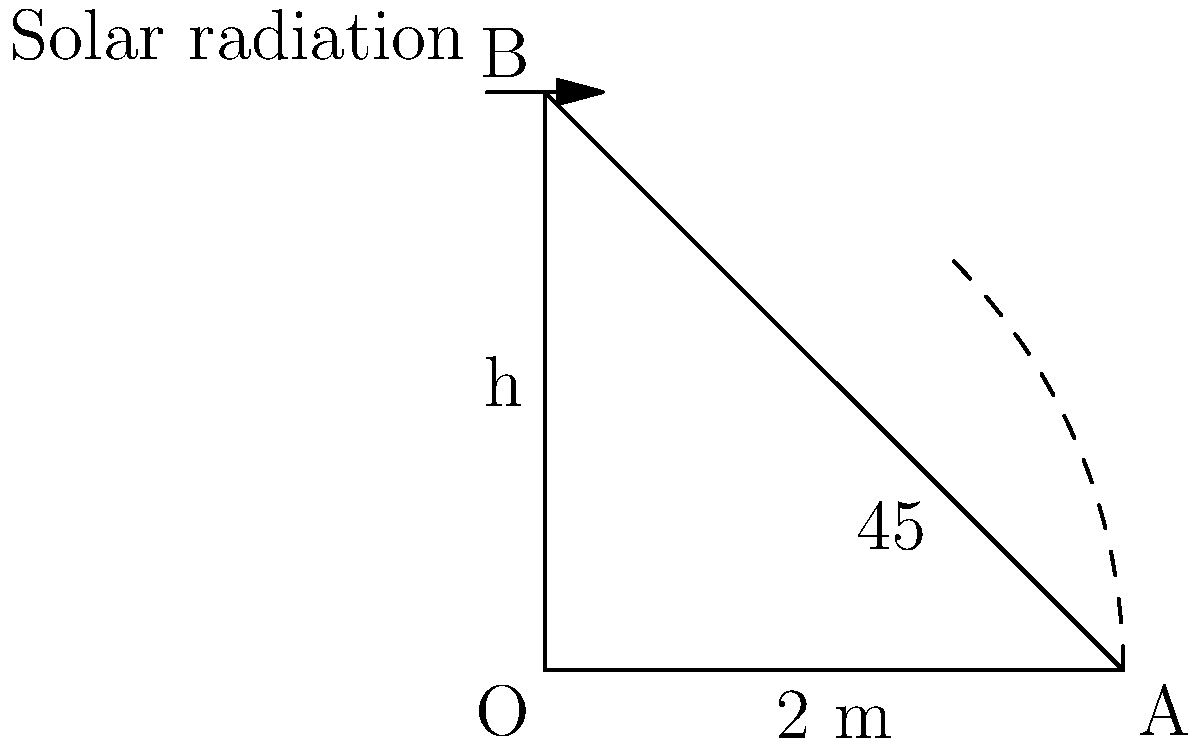A parabolic solar collector has a cross-section represented by the right-angled triangle OAB in the diagram. If the base of the collector (OA) is 2 meters long and the angle of incidence of solar radiation is 45°, calculate the height (h) of the collector and its efficiency in capturing solar energy. Assume that the efficiency is directly proportional to the ratio of the collector's height to its base length. Let's approach this step-by-step:

1) In the right-angled triangle OAB, we know:
   - The base (OA) is 2 meters
   - The angle at O is 45°

2) To find the height (h), we can use the tangent function:

   $$\tan 45° = \frac{h}{2}$$

3) We know that $\tan 45° = 1$, so:

   $$1 = \frac{h}{2}$$

4) Solving for h:

   $$h = 2 \text{ meters}$$

5) The efficiency is proportional to the ratio of height to base length:

   $$\text{Efficiency} \propto \frac{h}{\text{base length}} = \frac{2}{2} = 1$$

6) This ratio of 1 means the collector is capturing the maximum possible amount of solar radiation for its base length, which we can interpret as 100% efficiency.
Answer: Height (h) = 2 m, Efficiency = 100% 